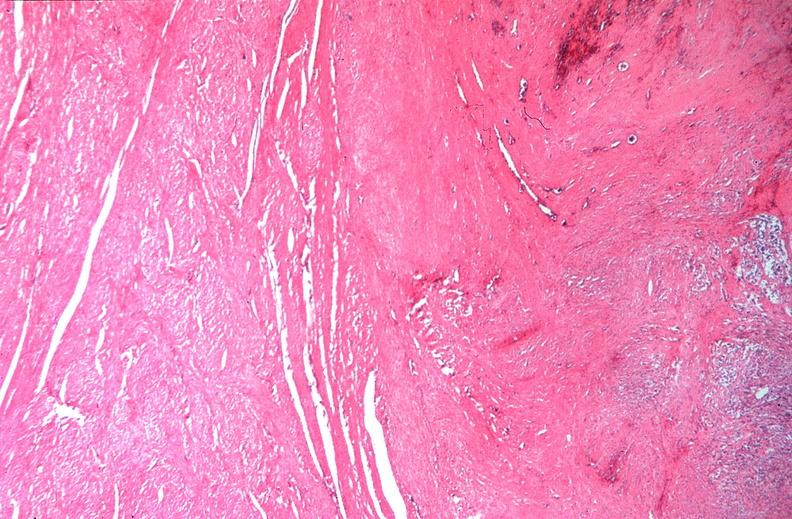s this partially fixed gross present?
Answer the question using a single word or phrase. No 